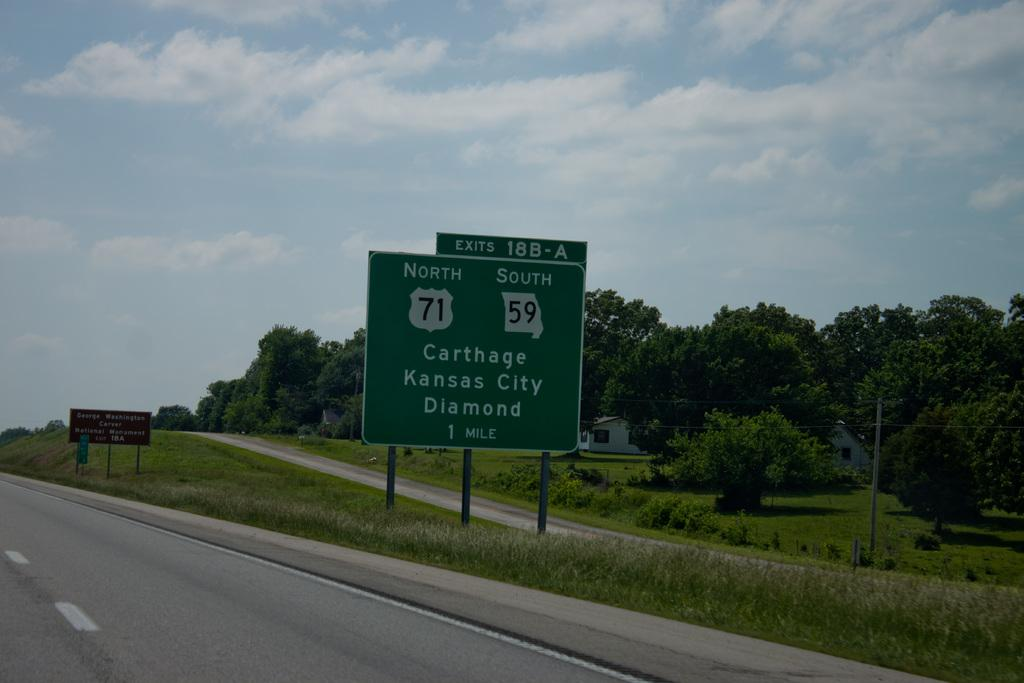<image>
Summarize the visual content of the image. The freeway sign says that the exit for Kansas City is in one mile. 